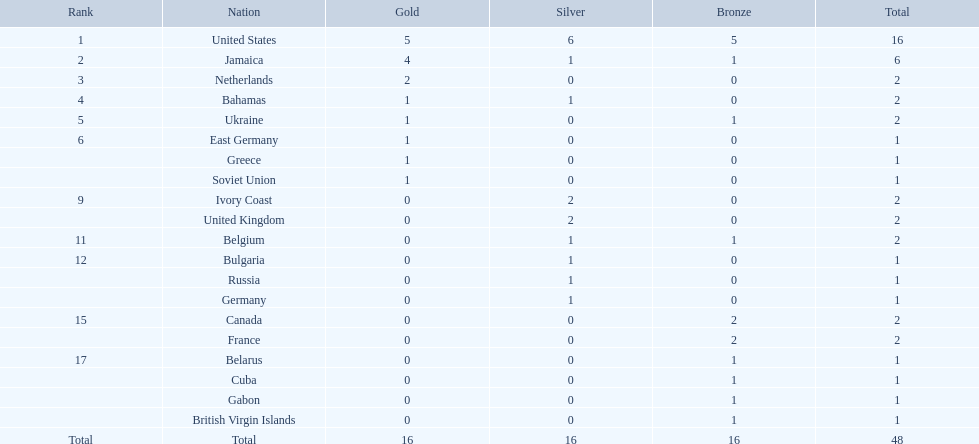Which countries participated? United States, Jamaica, Netherlands, Bahamas, Ukraine, East Germany, Greece, Soviet Union, Ivory Coast, United Kingdom, Belgium, Bulgaria, Russia, Germany, Canada, France, Belarus, Cuba, Gabon, British Virgin Islands. How many gold medals were won by each? 5, 4, 2, 1, 1, 1, 1, 1, 0, 0, 0, 0, 0, 0, 0, 0, 0, 0, 0, 0. And which country won the most? United States. 